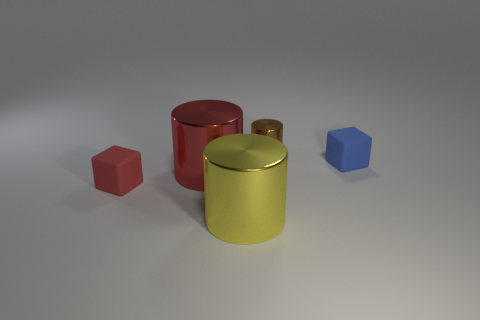There is a tiny object that is both in front of the small brown metallic cylinder and to the left of the blue matte object; what material is it?
Keep it short and to the point. Rubber. There is a block that is right of the yellow object; does it have the same size as the small brown cylinder?
Offer a terse response. Yes. What is the material of the yellow cylinder?
Give a very brief answer. Metal. There is a rubber cube on the left side of the yellow cylinder; what is its color?
Give a very brief answer. Red. How many small objects are yellow cylinders or spheres?
Make the answer very short. 0. Do the block that is left of the big yellow shiny thing and the big metal cylinder behind the tiny red matte thing have the same color?
Your answer should be very brief. Yes. What number of brown objects are tiny metal cylinders or tiny rubber cubes?
Keep it short and to the point. 1. There is a red rubber object; is it the same shape as the thing that is behind the small blue block?
Provide a short and direct response. No. There is a big red shiny thing; what shape is it?
Ensure brevity in your answer.  Cylinder. There is a red object that is the same size as the yellow cylinder; what is it made of?
Offer a very short reply. Metal. 